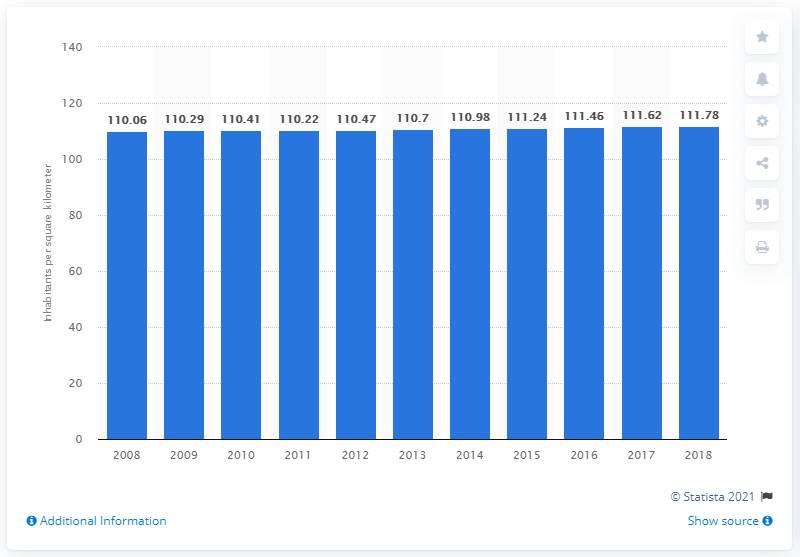Draw attention to some important aspects in this diagram. In 2018, the population density in the European Union was approximately 111.78 people per square kilometer. 